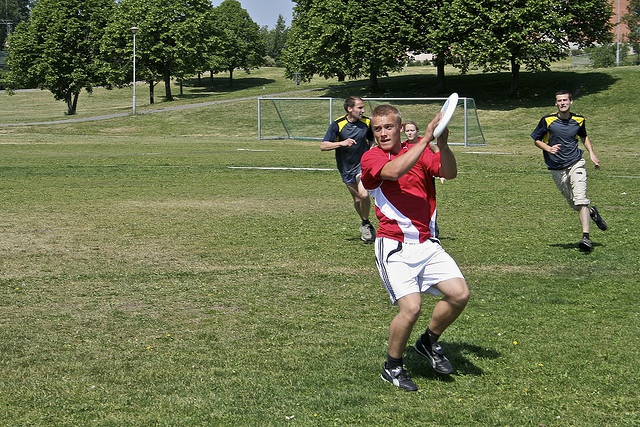Describe the objects in this image and their specific colors. I can see people in darkgreen, white, black, maroon, and gray tones, people in darkgreen, black, gray, lightgray, and darkgray tones, people in darkgreen, black, gray, and darkgray tones, frisbee in darkgreen, white, darkgray, and gray tones, and people in darkgreen, gray, maroon, pink, and darkgray tones in this image. 